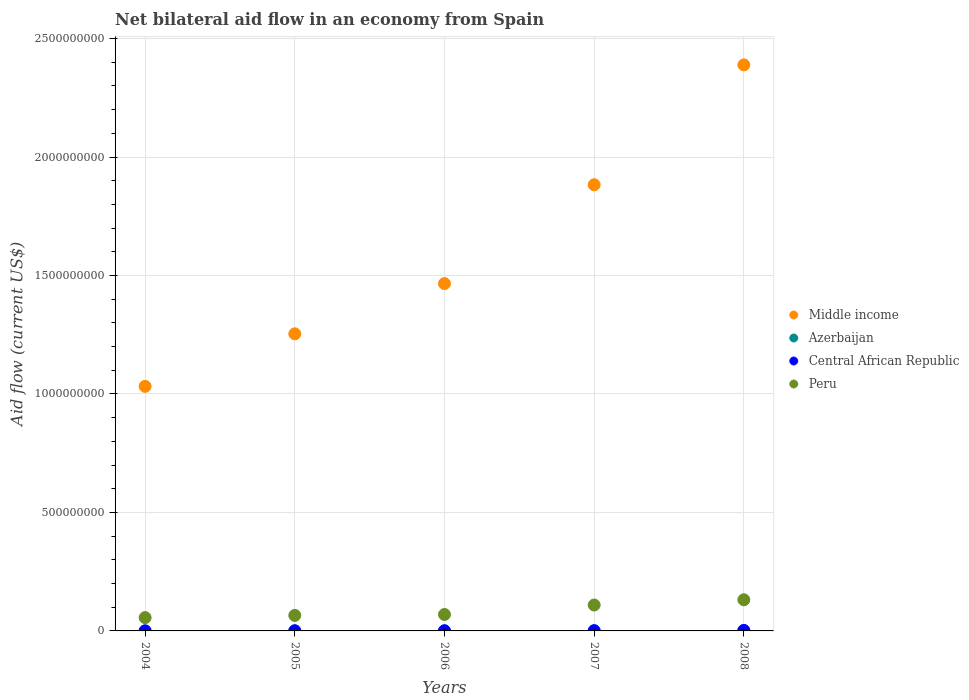How many different coloured dotlines are there?
Your answer should be compact. 4. What is the net bilateral aid flow in Central African Republic in 2008?
Offer a very short reply. 2.15e+06. Across all years, what is the maximum net bilateral aid flow in Peru?
Make the answer very short. 1.31e+08. Across all years, what is the minimum net bilateral aid flow in Peru?
Your response must be concise. 5.62e+07. What is the total net bilateral aid flow in Azerbaijan in the graph?
Provide a short and direct response. 6.20e+05. What is the difference between the net bilateral aid flow in Peru in 2005 and that in 2006?
Provide a short and direct response. -3.84e+06. What is the difference between the net bilateral aid flow in Middle income in 2004 and the net bilateral aid flow in Central African Republic in 2005?
Give a very brief answer. 1.03e+09. What is the average net bilateral aid flow in Azerbaijan per year?
Make the answer very short. 1.24e+05. In the year 2004, what is the difference between the net bilateral aid flow in Central African Republic and net bilateral aid flow in Middle income?
Provide a short and direct response. -1.03e+09. What is the ratio of the net bilateral aid flow in Azerbaijan in 2005 to that in 2006?
Your response must be concise. 0.64. What is the difference between the highest and the second highest net bilateral aid flow in Central African Republic?
Provide a short and direct response. 1.16e+06. What is the difference between the highest and the lowest net bilateral aid flow in Middle income?
Offer a very short reply. 1.36e+09. Is the net bilateral aid flow in Azerbaijan strictly greater than the net bilateral aid flow in Middle income over the years?
Ensure brevity in your answer.  No. Is the net bilateral aid flow in Peru strictly less than the net bilateral aid flow in Azerbaijan over the years?
Your response must be concise. No. Does the graph contain grids?
Ensure brevity in your answer.  Yes. Where does the legend appear in the graph?
Your response must be concise. Center right. How many legend labels are there?
Provide a short and direct response. 4. How are the legend labels stacked?
Your answer should be compact. Vertical. What is the title of the graph?
Your response must be concise. Net bilateral aid flow in an economy from Spain. Does "Congo (Republic)" appear as one of the legend labels in the graph?
Provide a short and direct response. No. What is the label or title of the X-axis?
Give a very brief answer. Years. What is the label or title of the Y-axis?
Your answer should be very brief. Aid flow (current US$). What is the Aid flow (current US$) of Middle income in 2004?
Offer a very short reply. 1.03e+09. What is the Aid flow (current US$) of Central African Republic in 2004?
Offer a terse response. 1.00e+05. What is the Aid flow (current US$) in Peru in 2004?
Offer a very short reply. 5.62e+07. What is the Aid flow (current US$) of Middle income in 2005?
Provide a short and direct response. 1.25e+09. What is the Aid flow (current US$) in Central African Republic in 2005?
Offer a terse response. 5.70e+05. What is the Aid flow (current US$) in Peru in 2005?
Make the answer very short. 6.55e+07. What is the Aid flow (current US$) of Middle income in 2006?
Offer a very short reply. 1.47e+09. What is the Aid flow (current US$) in Central African Republic in 2006?
Offer a terse response. 6.50e+05. What is the Aid flow (current US$) of Peru in 2006?
Your response must be concise. 6.94e+07. What is the Aid flow (current US$) of Middle income in 2007?
Your response must be concise. 1.88e+09. What is the Aid flow (current US$) of Azerbaijan in 2007?
Provide a short and direct response. 10000. What is the Aid flow (current US$) in Central African Republic in 2007?
Your answer should be compact. 9.90e+05. What is the Aid flow (current US$) in Peru in 2007?
Provide a short and direct response. 1.09e+08. What is the Aid flow (current US$) in Middle income in 2008?
Give a very brief answer. 2.39e+09. What is the Aid flow (current US$) in Azerbaijan in 2008?
Offer a terse response. 3.60e+05. What is the Aid flow (current US$) of Central African Republic in 2008?
Your answer should be compact. 2.15e+06. What is the Aid flow (current US$) of Peru in 2008?
Your answer should be compact. 1.31e+08. Across all years, what is the maximum Aid flow (current US$) in Middle income?
Offer a terse response. 2.39e+09. Across all years, what is the maximum Aid flow (current US$) of Azerbaijan?
Your answer should be very brief. 3.60e+05. Across all years, what is the maximum Aid flow (current US$) of Central African Republic?
Give a very brief answer. 2.15e+06. Across all years, what is the maximum Aid flow (current US$) of Peru?
Offer a very short reply. 1.31e+08. Across all years, what is the minimum Aid flow (current US$) in Middle income?
Make the answer very short. 1.03e+09. Across all years, what is the minimum Aid flow (current US$) in Azerbaijan?
Offer a terse response. 10000. Across all years, what is the minimum Aid flow (current US$) of Central African Republic?
Make the answer very short. 1.00e+05. Across all years, what is the minimum Aid flow (current US$) of Peru?
Your answer should be compact. 5.62e+07. What is the total Aid flow (current US$) in Middle income in the graph?
Your answer should be compact. 8.02e+09. What is the total Aid flow (current US$) in Azerbaijan in the graph?
Make the answer very short. 6.20e+05. What is the total Aid flow (current US$) in Central African Republic in the graph?
Make the answer very short. 4.46e+06. What is the total Aid flow (current US$) in Peru in the graph?
Offer a very short reply. 4.32e+08. What is the difference between the Aid flow (current US$) of Middle income in 2004 and that in 2005?
Provide a short and direct response. -2.22e+08. What is the difference between the Aid flow (current US$) in Azerbaijan in 2004 and that in 2005?
Make the answer very short. 0. What is the difference between the Aid flow (current US$) in Central African Republic in 2004 and that in 2005?
Offer a terse response. -4.70e+05. What is the difference between the Aid flow (current US$) of Peru in 2004 and that in 2005?
Give a very brief answer. -9.38e+06. What is the difference between the Aid flow (current US$) in Middle income in 2004 and that in 2006?
Offer a terse response. -4.34e+08. What is the difference between the Aid flow (current US$) in Central African Republic in 2004 and that in 2006?
Provide a short and direct response. -5.50e+05. What is the difference between the Aid flow (current US$) of Peru in 2004 and that in 2006?
Keep it short and to the point. -1.32e+07. What is the difference between the Aid flow (current US$) in Middle income in 2004 and that in 2007?
Offer a very short reply. -8.51e+08. What is the difference between the Aid flow (current US$) of Azerbaijan in 2004 and that in 2007?
Make the answer very short. 6.00e+04. What is the difference between the Aid flow (current US$) in Central African Republic in 2004 and that in 2007?
Provide a short and direct response. -8.90e+05. What is the difference between the Aid flow (current US$) in Peru in 2004 and that in 2007?
Make the answer very short. -5.32e+07. What is the difference between the Aid flow (current US$) of Middle income in 2004 and that in 2008?
Your answer should be very brief. -1.36e+09. What is the difference between the Aid flow (current US$) of Central African Republic in 2004 and that in 2008?
Make the answer very short. -2.05e+06. What is the difference between the Aid flow (current US$) in Peru in 2004 and that in 2008?
Your answer should be very brief. -7.53e+07. What is the difference between the Aid flow (current US$) of Middle income in 2005 and that in 2006?
Make the answer very short. -2.12e+08. What is the difference between the Aid flow (current US$) of Azerbaijan in 2005 and that in 2006?
Your answer should be compact. -4.00e+04. What is the difference between the Aid flow (current US$) of Central African Republic in 2005 and that in 2006?
Offer a very short reply. -8.00e+04. What is the difference between the Aid flow (current US$) in Peru in 2005 and that in 2006?
Give a very brief answer. -3.84e+06. What is the difference between the Aid flow (current US$) of Middle income in 2005 and that in 2007?
Offer a terse response. -6.29e+08. What is the difference between the Aid flow (current US$) in Azerbaijan in 2005 and that in 2007?
Offer a terse response. 6.00e+04. What is the difference between the Aid flow (current US$) in Central African Republic in 2005 and that in 2007?
Your answer should be compact. -4.20e+05. What is the difference between the Aid flow (current US$) in Peru in 2005 and that in 2007?
Provide a short and direct response. -4.38e+07. What is the difference between the Aid flow (current US$) of Middle income in 2005 and that in 2008?
Keep it short and to the point. -1.14e+09. What is the difference between the Aid flow (current US$) in Azerbaijan in 2005 and that in 2008?
Offer a very short reply. -2.90e+05. What is the difference between the Aid flow (current US$) in Central African Republic in 2005 and that in 2008?
Offer a terse response. -1.58e+06. What is the difference between the Aid flow (current US$) of Peru in 2005 and that in 2008?
Give a very brief answer. -6.60e+07. What is the difference between the Aid flow (current US$) of Middle income in 2006 and that in 2007?
Provide a succinct answer. -4.17e+08. What is the difference between the Aid flow (current US$) of Central African Republic in 2006 and that in 2007?
Your response must be concise. -3.40e+05. What is the difference between the Aid flow (current US$) in Peru in 2006 and that in 2007?
Your response must be concise. -4.00e+07. What is the difference between the Aid flow (current US$) in Middle income in 2006 and that in 2008?
Ensure brevity in your answer.  -9.23e+08. What is the difference between the Aid flow (current US$) in Central African Republic in 2006 and that in 2008?
Make the answer very short. -1.50e+06. What is the difference between the Aid flow (current US$) in Peru in 2006 and that in 2008?
Your response must be concise. -6.21e+07. What is the difference between the Aid flow (current US$) in Middle income in 2007 and that in 2008?
Provide a succinct answer. -5.06e+08. What is the difference between the Aid flow (current US$) in Azerbaijan in 2007 and that in 2008?
Keep it short and to the point. -3.50e+05. What is the difference between the Aid flow (current US$) of Central African Republic in 2007 and that in 2008?
Your response must be concise. -1.16e+06. What is the difference between the Aid flow (current US$) of Peru in 2007 and that in 2008?
Your answer should be very brief. -2.21e+07. What is the difference between the Aid flow (current US$) of Middle income in 2004 and the Aid flow (current US$) of Azerbaijan in 2005?
Your answer should be compact. 1.03e+09. What is the difference between the Aid flow (current US$) in Middle income in 2004 and the Aid flow (current US$) in Central African Republic in 2005?
Your answer should be compact. 1.03e+09. What is the difference between the Aid flow (current US$) of Middle income in 2004 and the Aid flow (current US$) of Peru in 2005?
Your response must be concise. 9.67e+08. What is the difference between the Aid flow (current US$) in Azerbaijan in 2004 and the Aid flow (current US$) in Central African Republic in 2005?
Provide a succinct answer. -5.00e+05. What is the difference between the Aid flow (current US$) of Azerbaijan in 2004 and the Aid flow (current US$) of Peru in 2005?
Give a very brief answer. -6.55e+07. What is the difference between the Aid flow (current US$) of Central African Republic in 2004 and the Aid flow (current US$) of Peru in 2005?
Make the answer very short. -6.54e+07. What is the difference between the Aid flow (current US$) in Middle income in 2004 and the Aid flow (current US$) in Azerbaijan in 2006?
Your answer should be very brief. 1.03e+09. What is the difference between the Aid flow (current US$) in Middle income in 2004 and the Aid flow (current US$) in Central African Republic in 2006?
Keep it short and to the point. 1.03e+09. What is the difference between the Aid flow (current US$) in Middle income in 2004 and the Aid flow (current US$) in Peru in 2006?
Provide a succinct answer. 9.63e+08. What is the difference between the Aid flow (current US$) of Azerbaijan in 2004 and the Aid flow (current US$) of Central African Republic in 2006?
Your answer should be very brief. -5.80e+05. What is the difference between the Aid flow (current US$) in Azerbaijan in 2004 and the Aid flow (current US$) in Peru in 2006?
Provide a short and direct response. -6.93e+07. What is the difference between the Aid flow (current US$) of Central African Republic in 2004 and the Aid flow (current US$) of Peru in 2006?
Your response must be concise. -6.93e+07. What is the difference between the Aid flow (current US$) in Middle income in 2004 and the Aid flow (current US$) in Azerbaijan in 2007?
Give a very brief answer. 1.03e+09. What is the difference between the Aid flow (current US$) in Middle income in 2004 and the Aid flow (current US$) in Central African Republic in 2007?
Your answer should be compact. 1.03e+09. What is the difference between the Aid flow (current US$) of Middle income in 2004 and the Aid flow (current US$) of Peru in 2007?
Ensure brevity in your answer.  9.23e+08. What is the difference between the Aid flow (current US$) of Azerbaijan in 2004 and the Aid flow (current US$) of Central African Republic in 2007?
Offer a very short reply. -9.20e+05. What is the difference between the Aid flow (current US$) in Azerbaijan in 2004 and the Aid flow (current US$) in Peru in 2007?
Keep it short and to the point. -1.09e+08. What is the difference between the Aid flow (current US$) of Central African Republic in 2004 and the Aid flow (current US$) of Peru in 2007?
Your answer should be compact. -1.09e+08. What is the difference between the Aid flow (current US$) in Middle income in 2004 and the Aid flow (current US$) in Azerbaijan in 2008?
Offer a very short reply. 1.03e+09. What is the difference between the Aid flow (current US$) of Middle income in 2004 and the Aid flow (current US$) of Central African Republic in 2008?
Ensure brevity in your answer.  1.03e+09. What is the difference between the Aid flow (current US$) in Middle income in 2004 and the Aid flow (current US$) in Peru in 2008?
Provide a short and direct response. 9.01e+08. What is the difference between the Aid flow (current US$) in Azerbaijan in 2004 and the Aid flow (current US$) in Central African Republic in 2008?
Ensure brevity in your answer.  -2.08e+06. What is the difference between the Aid flow (current US$) in Azerbaijan in 2004 and the Aid flow (current US$) in Peru in 2008?
Your answer should be compact. -1.31e+08. What is the difference between the Aid flow (current US$) in Central African Republic in 2004 and the Aid flow (current US$) in Peru in 2008?
Give a very brief answer. -1.31e+08. What is the difference between the Aid flow (current US$) of Middle income in 2005 and the Aid flow (current US$) of Azerbaijan in 2006?
Offer a terse response. 1.25e+09. What is the difference between the Aid flow (current US$) of Middle income in 2005 and the Aid flow (current US$) of Central African Republic in 2006?
Offer a terse response. 1.25e+09. What is the difference between the Aid flow (current US$) of Middle income in 2005 and the Aid flow (current US$) of Peru in 2006?
Ensure brevity in your answer.  1.18e+09. What is the difference between the Aid flow (current US$) of Azerbaijan in 2005 and the Aid flow (current US$) of Central African Republic in 2006?
Make the answer very short. -5.80e+05. What is the difference between the Aid flow (current US$) of Azerbaijan in 2005 and the Aid flow (current US$) of Peru in 2006?
Provide a short and direct response. -6.93e+07. What is the difference between the Aid flow (current US$) in Central African Republic in 2005 and the Aid flow (current US$) in Peru in 2006?
Ensure brevity in your answer.  -6.88e+07. What is the difference between the Aid flow (current US$) of Middle income in 2005 and the Aid flow (current US$) of Azerbaijan in 2007?
Your answer should be very brief. 1.25e+09. What is the difference between the Aid flow (current US$) of Middle income in 2005 and the Aid flow (current US$) of Central African Republic in 2007?
Make the answer very short. 1.25e+09. What is the difference between the Aid flow (current US$) of Middle income in 2005 and the Aid flow (current US$) of Peru in 2007?
Provide a succinct answer. 1.14e+09. What is the difference between the Aid flow (current US$) of Azerbaijan in 2005 and the Aid flow (current US$) of Central African Republic in 2007?
Give a very brief answer. -9.20e+05. What is the difference between the Aid flow (current US$) of Azerbaijan in 2005 and the Aid flow (current US$) of Peru in 2007?
Give a very brief answer. -1.09e+08. What is the difference between the Aid flow (current US$) in Central African Republic in 2005 and the Aid flow (current US$) in Peru in 2007?
Your answer should be compact. -1.09e+08. What is the difference between the Aid flow (current US$) in Middle income in 2005 and the Aid flow (current US$) in Azerbaijan in 2008?
Give a very brief answer. 1.25e+09. What is the difference between the Aid flow (current US$) of Middle income in 2005 and the Aid flow (current US$) of Central African Republic in 2008?
Provide a succinct answer. 1.25e+09. What is the difference between the Aid flow (current US$) of Middle income in 2005 and the Aid flow (current US$) of Peru in 2008?
Provide a short and direct response. 1.12e+09. What is the difference between the Aid flow (current US$) of Azerbaijan in 2005 and the Aid flow (current US$) of Central African Republic in 2008?
Your response must be concise. -2.08e+06. What is the difference between the Aid flow (current US$) in Azerbaijan in 2005 and the Aid flow (current US$) in Peru in 2008?
Ensure brevity in your answer.  -1.31e+08. What is the difference between the Aid flow (current US$) in Central African Republic in 2005 and the Aid flow (current US$) in Peru in 2008?
Offer a very short reply. -1.31e+08. What is the difference between the Aid flow (current US$) in Middle income in 2006 and the Aid flow (current US$) in Azerbaijan in 2007?
Offer a very short reply. 1.47e+09. What is the difference between the Aid flow (current US$) of Middle income in 2006 and the Aid flow (current US$) of Central African Republic in 2007?
Keep it short and to the point. 1.46e+09. What is the difference between the Aid flow (current US$) in Middle income in 2006 and the Aid flow (current US$) in Peru in 2007?
Your answer should be compact. 1.36e+09. What is the difference between the Aid flow (current US$) in Azerbaijan in 2006 and the Aid flow (current US$) in Central African Republic in 2007?
Offer a terse response. -8.80e+05. What is the difference between the Aid flow (current US$) in Azerbaijan in 2006 and the Aid flow (current US$) in Peru in 2007?
Your answer should be compact. -1.09e+08. What is the difference between the Aid flow (current US$) of Central African Republic in 2006 and the Aid flow (current US$) of Peru in 2007?
Offer a very short reply. -1.09e+08. What is the difference between the Aid flow (current US$) of Middle income in 2006 and the Aid flow (current US$) of Azerbaijan in 2008?
Make the answer very short. 1.47e+09. What is the difference between the Aid flow (current US$) in Middle income in 2006 and the Aid flow (current US$) in Central African Republic in 2008?
Make the answer very short. 1.46e+09. What is the difference between the Aid flow (current US$) in Middle income in 2006 and the Aid flow (current US$) in Peru in 2008?
Offer a very short reply. 1.33e+09. What is the difference between the Aid flow (current US$) of Azerbaijan in 2006 and the Aid flow (current US$) of Central African Republic in 2008?
Provide a short and direct response. -2.04e+06. What is the difference between the Aid flow (current US$) in Azerbaijan in 2006 and the Aid flow (current US$) in Peru in 2008?
Your answer should be compact. -1.31e+08. What is the difference between the Aid flow (current US$) of Central African Republic in 2006 and the Aid flow (current US$) of Peru in 2008?
Offer a terse response. -1.31e+08. What is the difference between the Aid flow (current US$) in Middle income in 2007 and the Aid flow (current US$) in Azerbaijan in 2008?
Your response must be concise. 1.88e+09. What is the difference between the Aid flow (current US$) in Middle income in 2007 and the Aid flow (current US$) in Central African Republic in 2008?
Provide a succinct answer. 1.88e+09. What is the difference between the Aid flow (current US$) in Middle income in 2007 and the Aid flow (current US$) in Peru in 2008?
Give a very brief answer. 1.75e+09. What is the difference between the Aid flow (current US$) in Azerbaijan in 2007 and the Aid flow (current US$) in Central African Republic in 2008?
Your response must be concise. -2.14e+06. What is the difference between the Aid flow (current US$) of Azerbaijan in 2007 and the Aid flow (current US$) of Peru in 2008?
Give a very brief answer. -1.31e+08. What is the difference between the Aid flow (current US$) in Central African Republic in 2007 and the Aid flow (current US$) in Peru in 2008?
Ensure brevity in your answer.  -1.30e+08. What is the average Aid flow (current US$) of Middle income per year?
Offer a terse response. 1.60e+09. What is the average Aid flow (current US$) in Azerbaijan per year?
Your response must be concise. 1.24e+05. What is the average Aid flow (current US$) in Central African Republic per year?
Ensure brevity in your answer.  8.92e+05. What is the average Aid flow (current US$) in Peru per year?
Provide a succinct answer. 8.64e+07. In the year 2004, what is the difference between the Aid flow (current US$) of Middle income and Aid flow (current US$) of Azerbaijan?
Offer a very short reply. 1.03e+09. In the year 2004, what is the difference between the Aid flow (current US$) in Middle income and Aid flow (current US$) in Central African Republic?
Your response must be concise. 1.03e+09. In the year 2004, what is the difference between the Aid flow (current US$) of Middle income and Aid flow (current US$) of Peru?
Your answer should be very brief. 9.76e+08. In the year 2004, what is the difference between the Aid flow (current US$) of Azerbaijan and Aid flow (current US$) of Central African Republic?
Offer a terse response. -3.00e+04. In the year 2004, what is the difference between the Aid flow (current US$) in Azerbaijan and Aid flow (current US$) in Peru?
Your answer should be compact. -5.61e+07. In the year 2004, what is the difference between the Aid flow (current US$) in Central African Republic and Aid flow (current US$) in Peru?
Your response must be concise. -5.60e+07. In the year 2005, what is the difference between the Aid flow (current US$) in Middle income and Aid flow (current US$) in Azerbaijan?
Your response must be concise. 1.25e+09. In the year 2005, what is the difference between the Aid flow (current US$) in Middle income and Aid flow (current US$) in Central African Republic?
Make the answer very short. 1.25e+09. In the year 2005, what is the difference between the Aid flow (current US$) of Middle income and Aid flow (current US$) of Peru?
Keep it short and to the point. 1.19e+09. In the year 2005, what is the difference between the Aid flow (current US$) in Azerbaijan and Aid flow (current US$) in Central African Republic?
Your answer should be compact. -5.00e+05. In the year 2005, what is the difference between the Aid flow (current US$) in Azerbaijan and Aid flow (current US$) in Peru?
Your answer should be very brief. -6.55e+07. In the year 2005, what is the difference between the Aid flow (current US$) of Central African Republic and Aid flow (current US$) of Peru?
Your answer should be compact. -6.50e+07. In the year 2006, what is the difference between the Aid flow (current US$) in Middle income and Aid flow (current US$) in Azerbaijan?
Provide a succinct answer. 1.47e+09. In the year 2006, what is the difference between the Aid flow (current US$) of Middle income and Aid flow (current US$) of Central African Republic?
Offer a terse response. 1.47e+09. In the year 2006, what is the difference between the Aid flow (current US$) of Middle income and Aid flow (current US$) of Peru?
Ensure brevity in your answer.  1.40e+09. In the year 2006, what is the difference between the Aid flow (current US$) of Azerbaijan and Aid flow (current US$) of Central African Republic?
Ensure brevity in your answer.  -5.40e+05. In the year 2006, what is the difference between the Aid flow (current US$) in Azerbaijan and Aid flow (current US$) in Peru?
Your response must be concise. -6.93e+07. In the year 2006, what is the difference between the Aid flow (current US$) in Central African Republic and Aid flow (current US$) in Peru?
Ensure brevity in your answer.  -6.87e+07. In the year 2007, what is the difference between the Aid flow (current US$) of Middle income and Aid flow (current US$) of Azerbaijan?
Provide a short and direct response. 1.88e+09. In the year 2007, what is the difference between the Aid flow (current US$) of Middle income and Aid flow (current US$) of Central African Republic?
Ensure brevity in your answer.  1.88e+09. In the year 2007, what is the difference between the Aid flow (current US$) in Middle income and Aid flow (current US$) in Peru?
Offer a terse response. 1.77e+09. In the year 2007, what is the difference between the Aid flow (current US$) in Azerbaijan and Aid flow (current US$) in Central African Republic?
Ensure brevity in your answer.  -9.80e+05. In the year 2007, what is the difference between the Aid flow (current US$) in Azerbaijan and Aid flow (current US$) in Peru?
Make the answer very short. -1.09e+08. In the year 2007, what is the difference between the Aid flow (current US$) of Central African Republic and Aid flow (current US$) of Peru?
Offer a terse response. -1.08e+08. In the year 2008, what is the difference between the Aid flow (current US$) of Middle income and Aid flow (current US$) of Azerbaijan?
Ensure brevity in your answer.  2.39e+09. In the year 2008, what is the difference between the Aid flow (current US$) of Middle income and Aid flow (current US$) of Central African Republic?
Offer a terse response. 2.39e+09. In the year 2008, what is the difference between the Aid flow (current US$) in Middle income and Aid flow (current US$) in Peru?
Give a very brief answer. 2.26e+09. In the year 2008, what is the difference between the Aid flow (current US$) in Azerbaijan and Aid flow (current US$) in Central African Republic?
Keep it short and to the point. -1.79e+06. In the year 2008, what is the difference between the Aid flow (current US$) of Azerbaijan and Aid flow (current US$) of Peru?
Keep it short and to the point. -1.31e+08. In the year 2008, what is the difference between the Aid flow (current US$) of Central African Republic and Aid flow (current US$) of Peru?
Your response must be concise. -1.29e+08. What is the ratio of the Aid flow (current US$) of Middle income in 2004 to that in 2005?
Your response must be concise. 0.82. What is the ratio of the Aid flow (current US$) of Azerbaijan in 2004 to that in 2005?
Offer a very short reply. 1. What is the ratio of the Aid flow (current US$) of Central African Republic in 2004 to that in 2005?
Your answer should be compact. 0.18. What is the ratio of the Aid flow (current US$) in Peru in 2004 to that in 2005?
Give a very brief answer. 0.86. What is the ratio of the Aid flow (current US$) of Middle income in 2004 to that in 2006?
Your answer should be compact. 0.7. What is the ratio of the Aid flow (current US$) in Azerbaijan in 2004 to that in 2006?
Offer a terse response. 0.64. What is the ratio of the Aid flow (current US$) of Central African Republic in 2004 to that in 2006?
Your answer should be very brief. 0.15. What is the ratio of the Aid flow (current US$) of Peru in 2004 to that in 2006?
Give a very brief answer. 0.81. What is the ratio of the Aid flow (current US$) in Middle income in 2004 to that in 2007?
Your answer should be very brief. 0.55. What is the ratio of the Aid flow (current US$) of Azerbaijan in 2004 to that in 2007?
Offer a terse response. 7. What is the ratio of the Aid flow (current US$) in Central African Republic in 2004 to that in 2007?
Give a very brief answer. 0.1. What is the ratio of the Aid flow (current US$) of Peru in 2004 to that in 2007?
Your answer should be very brief. 0.51. What is the ratio of the Aid flow (current US$) in Middle income in 2004 to that in 2008?
Provide a short and direct response. 0.43. What is the ratio of the Aid flow (current US$) in Azerbaijan in 2004 to that in 2008?
Offer a very short reply. 0.19. What is the ratio of the Aid flow (current US$) in Central African Republic in 2004 to that in 2008?
Make the answer very short. 0.05. What is the ratio of the Aid flow (current US$) of Peru in 2004 to that in 2008?
Make the answer very short. 0.43. What is the ratio of the Aid flow (current US$) in Middle income in 2005 to that in 2006?
Keep it short and to the point. 0.86. What is the ratio of the Aid flow (current US$) of Azerbaijan in 2005 to that in 2006?
Offer a very short reply. 0.64. What is the ratio of the Aid flow (current US$) in Central African Republic in 2005 to that in 2006?
Make the answer very short. 0.88. What is the ratio of the Aid flow (current US$) in Peru in 2005 to that in 2006?
Give a very brief answer. 0.94. What is the ratio of the Aid flow (current US$) of Middle income in 2005 to that in 2007?
Make the answer very short. 0.67. What is the ratio of the Aid flow (current US$) in Central African Republic in 2005 to that in 2007?
Your response must be concise. 0.58. What is the ratio of the Aid flow (current US$) of Peru in 2005 to that in 2007?
Offer a terse response. 0.6. What is the ratio of the Aid flow (current US$) in Middle income in 2005 to that in 2008?
Ensure brevity in your answer.  0.52. What is the ratio of the Aid flow (current US$) of Azerbaijan in 2005 to that in 2008?
Your response must be concise. 0.19. What is the ratio of the Aid flow (current US$) in Central African Republic in 2005 to that in 2008?
Provide a short and direct response. 0.27. What is the ratio of the Aid flow (current US$) in Peru in 2005 to that in 2008?
Your response must be concise. 0.5. What is the ratio of the Aid flow (current US$) in Middle income in 2006 to that in 2007?
Your answer should be compact. 0.78. What is the ratio of the Aid flow (current US$) of Azerbaijan in 2006 to that in 2007?
Your response must be concise. 11. What is the ratio of the Aid flow (current US$) in Central African Republic in 2006 to that in 2007?
Ensure brevity in your answer.  0.66. What is the ratio of the Aid flow (current US$) in Peru in 2006 to that in 2007?
Provide a succinct answer. 0.63. What is the ratio of the Aid flow (current US$) of Middle income in 2006 to that in 2008?
Make the answer very short. 0.61. What is the ratio of the Aid flow (current US$) in Azerbaijan in 2006 to that in 2008?
Ensure brevity in your answer.  0.31. What is the ratio of the Aid flow (current US$) of Central African Republic in 2006 to that in 2008?
Give a very brief answer. 0.3. What is the ratio of the Aid flow (current US$) of Peru in 2006 to that in 2008?
Your response must be concise. 0.53. What is the ratio of the Aid flow (current US$) of Middle income in 2007 to that in 2008?
Keep it short and to the point. 0.79. What is the ratio of the Aid flow (current US$) in Azerbaijan in 2007 to that in 2008?
Your answer should be very brief. 0.03. What is the ratio of the Aid flow (current US$) of Central African Republic in 2007 to that in 2008?
Your response must be concise. 0.46. What is the ratio of the Aid flow (current US$) of Peru in 2007 to that in 2008?
Your response must be concise. 0.83. What is the difference between the highest and the second highest Aid flow (current US$) of Middle income?
Your answer should be very brief. 5.06e+08. What is the difference between the highest and the second highest Aid flow (current US$) in Central African Republic?
Provide a succinct answer. 1.16e+06. What is the difference between the highest and the second highest Aid flow (current US$) of Peru?
Your response must be concise. 2.21e+07. What is the difference between the highest and the lowest Aid flow (current US$) in Middle income?
Provide a succinct answer. 1.36e+09. What is the difference between the highest and the lowest Aid flow (current US$) in Azerbaijan?
Your answer should be compact. 3.50e+05. What is the difference between the highest and the lowest Aid flow (current US$) in Central African Republic?
Provide a succinct answer. 2.05e+06. What is the difference between the highest and the lowest Aid flow (current US$) in Peru?
Ensure brevity in your answer.  7.53e+07. 